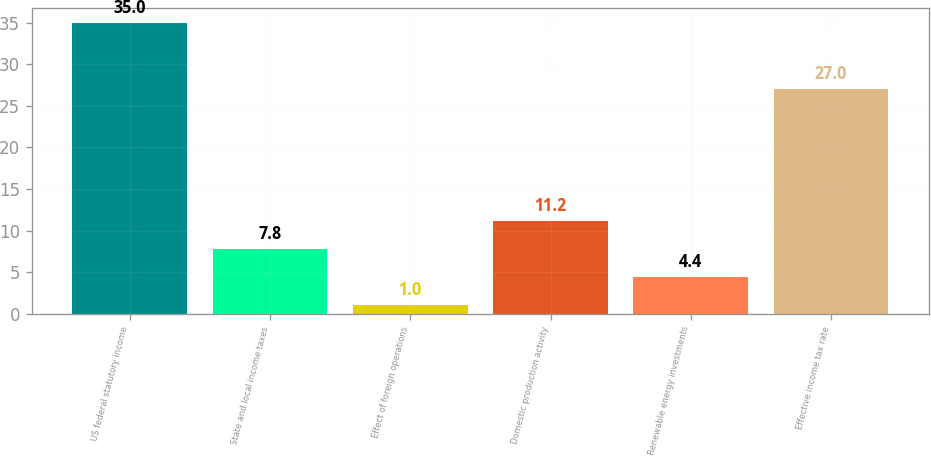<chart> <loc_0><loc_0><loc_500><loc_500><bar_chart><fcel>US federal statutory income<fcel>State and local income taxes<fcel>Effect of foreign operations<fcel>Domestic production activity<fcel>Renewable energy investments<fcel>Effective income tax rate<nl><fcel>35<fcel>7.8<fcel>1<fcel>11.2<fcel>4.4<fcel>27<nl></chart> 